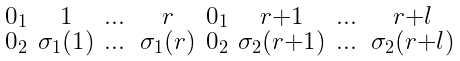Convert formula to latex. <formula><loc_0><loc_0><loc_500><loc_500>\begin{smallmatrix} 0 _ { 1 } & 1 & \dots & r & 0 _ { 1 } & r + 1 & \dots & r + l \\ 0 _ { 2 } & \sigma _ { 1 } ( 1 ) & \dots & \sigma _ { 1 } ( r ) & 0 _ { 2 } & \sigma _ { 2 } ( r + 1 ) & \dots & \sigma _ { 2 } ( r + l ) \end{smallmatrix}</formula> 